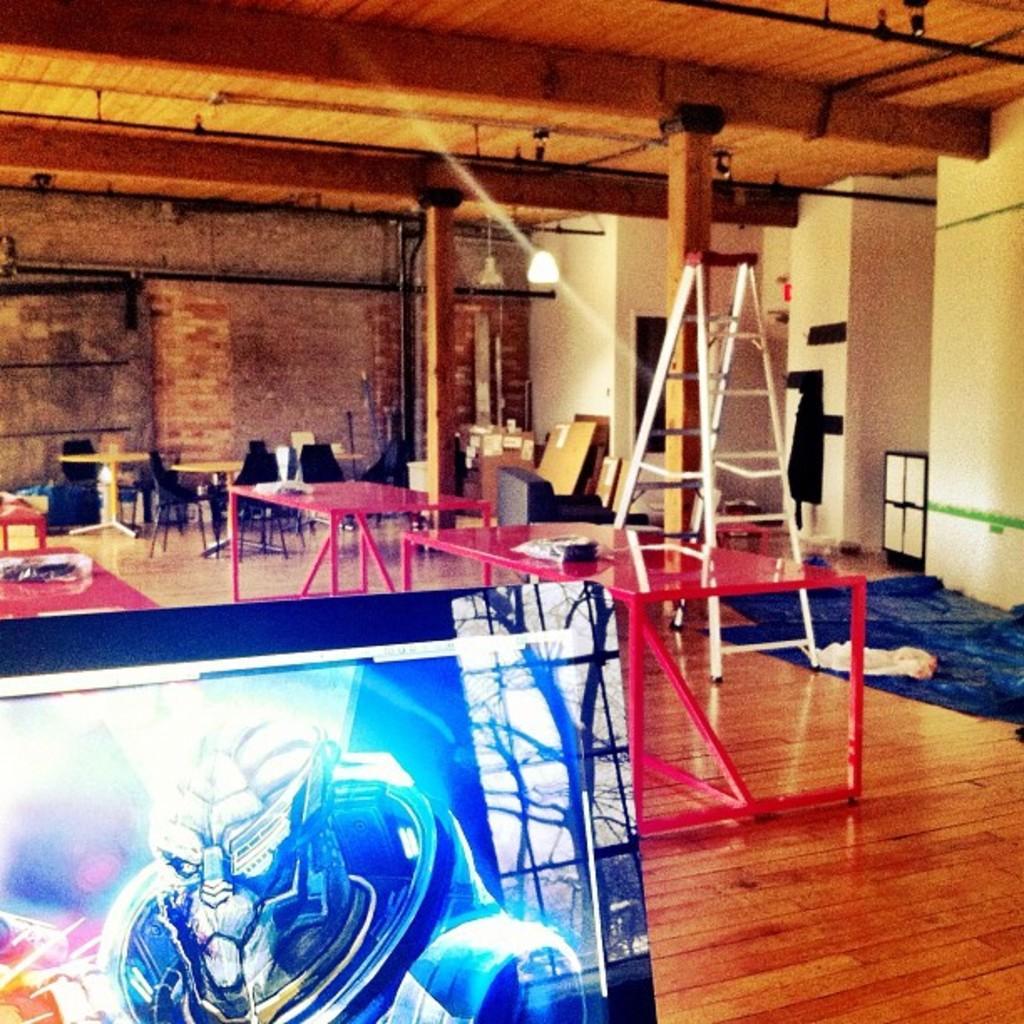How would you summarize this image in a sentence or two? In this image I can see in side view of the building and on the floor I can see tables , chair , clothes, on the table I can see a stand , in the bottom left there is a board , on the board there is a graphic image, at the top there is a roof, on the roof there is a light , in the middle there are poles , beams and lights visible. 